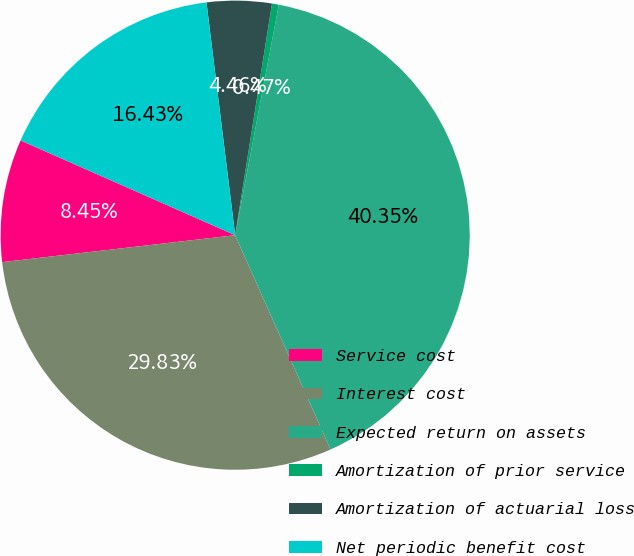Convert chart to OTSL. <chart><loc_0><loc_0><loc_500><loc_500><pie_chart><fcel>Service cost<fcel>Interest cost<fcel>Expected return on assets<fcel>Amortization of prior service<fcel>Amortization of actuarial loss<fcel>Net periodic benefit cost<nl><fcel>8.45%<fcel>29.83%<fcel>40.35%<fcel>0.47%<fcel>4.46%<fcel>16.43%<nl></chart> 